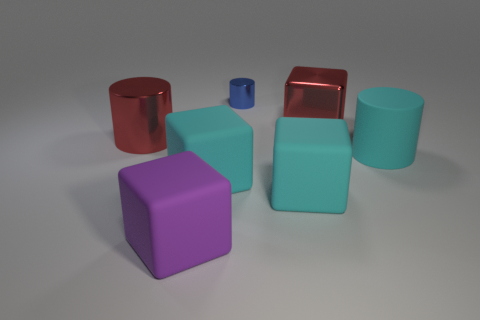Subtract all shiny cylinders. How many cylinders are left? 1 Subtract all red balls. How many cyan blocks are left? 2 Subtract all cyan blocks. How many blocks are left? 2 Subtract 1 cylinders. How many cylinders are left? 2 Add 1 big purple rubber blocks. How many objects exist? 8 Subtract 0 blue balls. How many objects are left? 7 Subtract all cylinders. How many objects are left? 4 Subtract all red cubes. Subtract all red cylinders. How many cubes are left? 3 Subtract all small blue metallic cylinders. Subtract all large red objects. How many objects are left? 4 Add 5 cyan cubes. How many cyan cubes are left? 7 